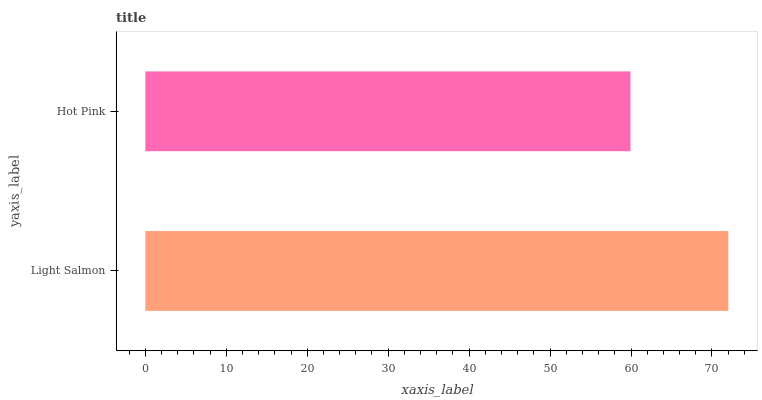Is Hot Pink the minimum?
Answer yes or no. Yes. Is Light Salmon the maximum?
Answer yes or no. Yes. Is Hot Pink the maximum?
Answer yes or no. No. Is Light Salmon greater than Hot Pink?
Answer yes or no. Yes. Is Hot Pink less than Light Salmon?
Answer yes or no. Yes. Is Hot Pink greater than Light Salmon?
Answer yes or no. No. Is Light Salmon less than Hot Pink?
Answer yes or no. No. Is Light Salmon the high median?
Answer yes or no. Yes. Is Hot Pink the low median?
Answer yes or no. Yes. Is Hot Pink the high median?
Answer yes or no. No. Is Light Salmon the low median?
Answer yes or no. No. 